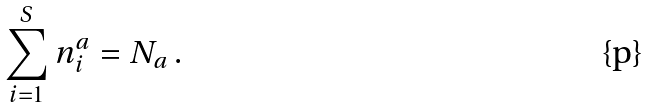Convert formula to latex. <formula><loc_0><loc_0><loc_500><loc_500>\sum _ { i = 1 } ^ { S } n _ { i } ^ { a } = N _ { a } \, .</formula> 